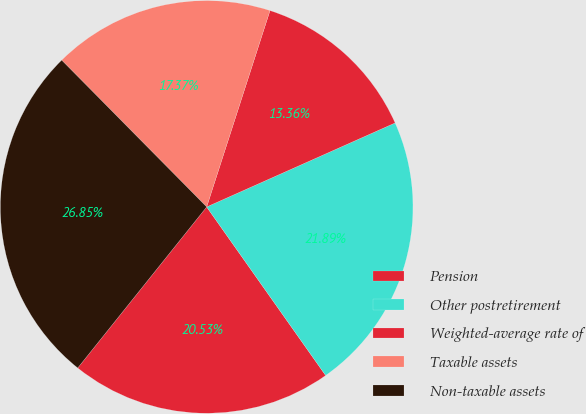<chart> <loc_0><loc_0><loc_500><loc_500><pie_chart><fcel>Pension<fcel>Other postretirement<fcel>Weighted-average rate of<fcel>Taxable assets<fcel>Non-taxable assets<nl><fcel>20.53%<fcel>21.89%<fcel>13.36%<fcel>17.37%<fcel>26.85%<nl></chart> 